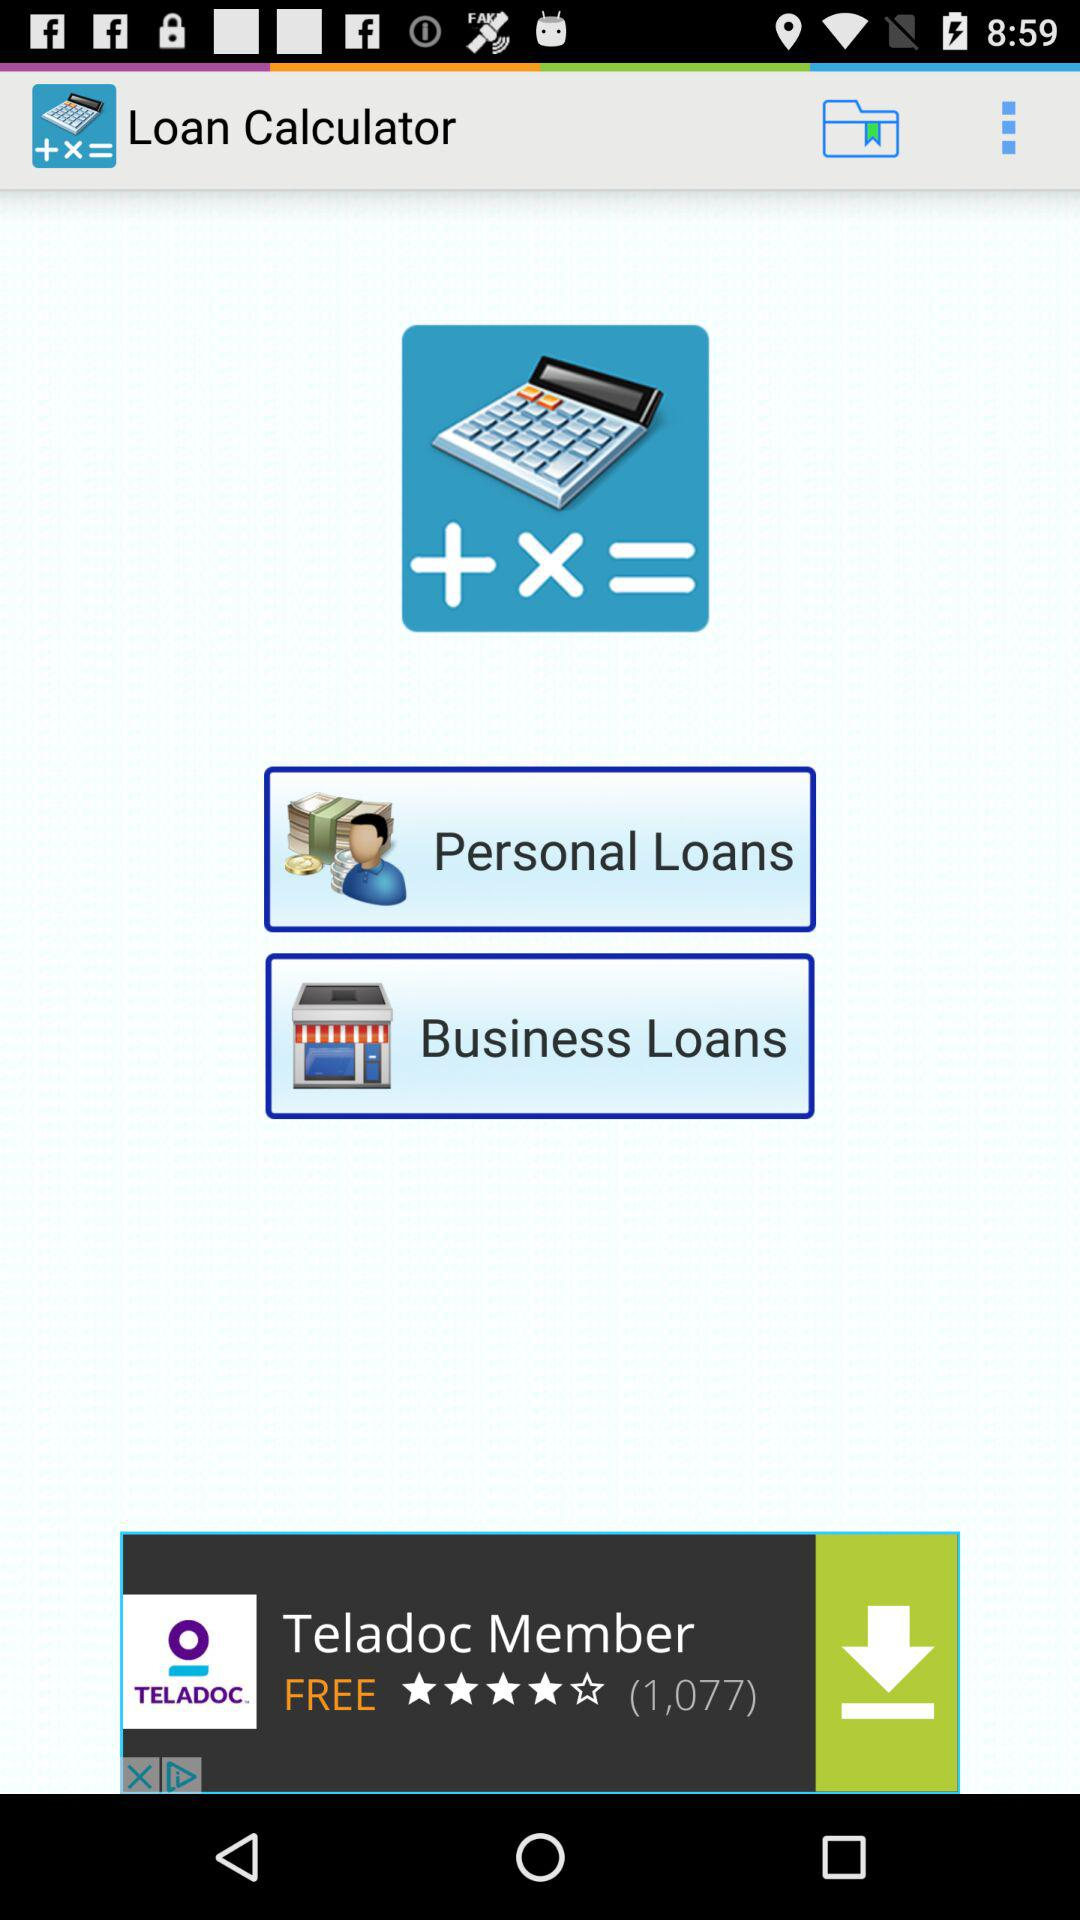What are the loan options shown on the screen? The shown options are "Personal Loans" and "Business Loans". 